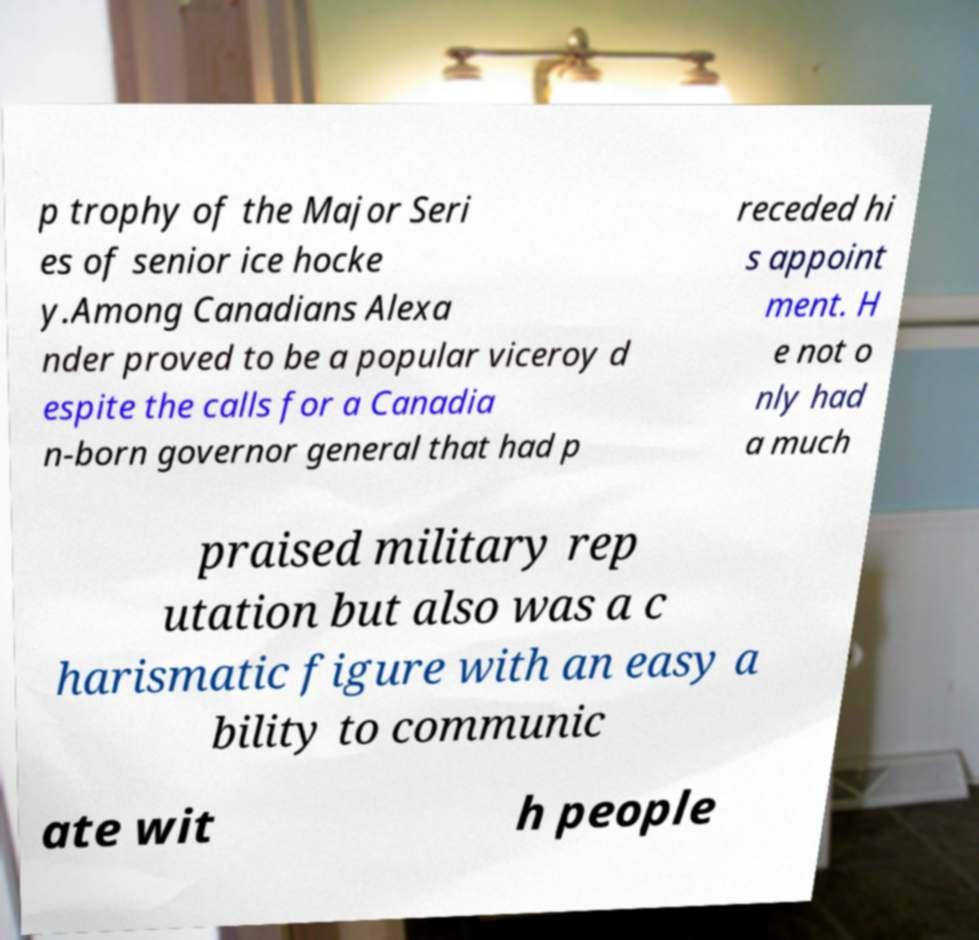What messages or text are displayed in this image? I need them in a readable, typed format. p trophy of the Major Seri es of senior ice hocke y.Among Canadians Alexa nder proved to be a popular viceroy d espite the calls for a Canadia n-born governor general that had p receded hi s appoint ment. H e not o nly had a much praised military rep utation but also was a c harismatic figure with an easy a bility to communic ate wit h people 